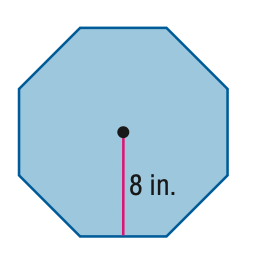Answer the mathemtical geometry problem and directly provide the correct option letter.
Question: Find the area of the regular polygon. Round to the nearest tenth.
Choices: A: 26.5 B: 106.1 C: 212.1 D: 424.2 C 